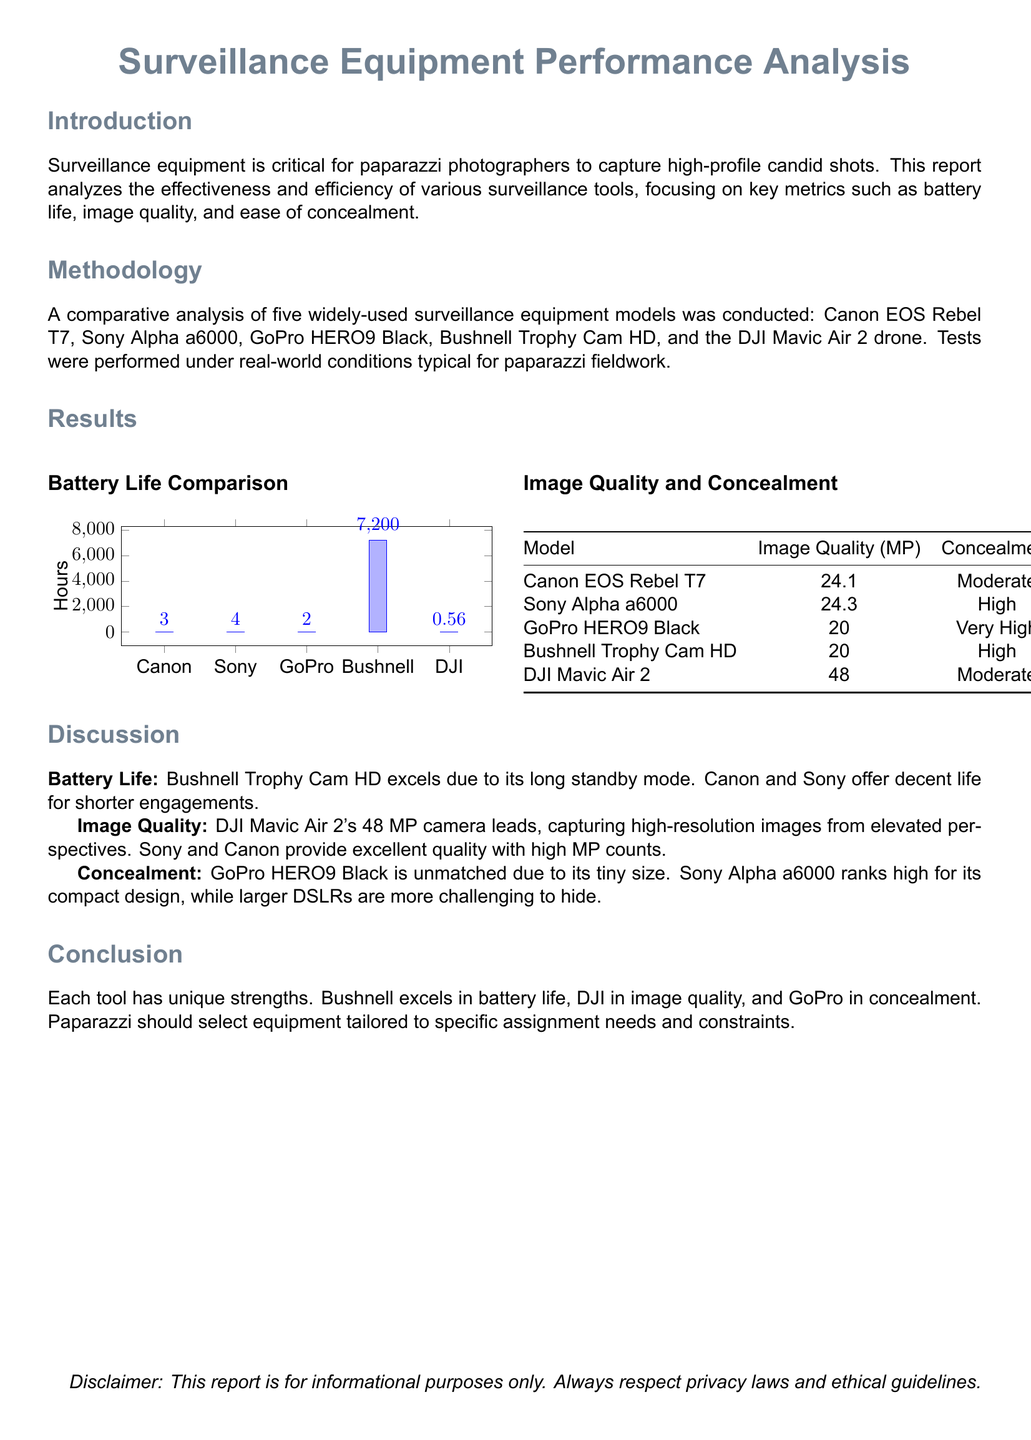What is the title of the report? The title of the report is presented prominently at the beginning of the document.
Answer: Surveillance Equipment Performance Analysis How many hours of battery life does the Bushnell Trophy Cam HD have? The battery life of the Bushnell Trophy Cam HD is indicated in the comparison graph in the results section.
Answer: 7200 What is the image quality in megapixels of the Sony Alpha a6000? The image quality of the Sony Alpha a6000 is detailed in the table within the results section.
Answer: 24.3 Which equipment model has the highest image quality? The model with the highest image quality is listed in the table under the image quality section.
Answer: DJI Mavic Air 2 What is the concealment rating of the GoPro HERO9 Black? The concealment rating for the GoPro HERO9 Black can be found in the comparative table.
Answer: Very High Which equipment excels in battery life? The discussion section reviews the equipment performance and identifies which excels in battery life.
Answer: Bushnell Trophy Cam HD What is the main focus of the report? The introduction outlines the report's emphasis on specific metrics relevant to surveillance equipment.
Answer: Effectiveness and efficiency Which two models offer decent battery life for shorter engagements? The discussion identifies specific models that provide adequate battery life suitable for shorter use cases.
Answer: Canon and Sony 